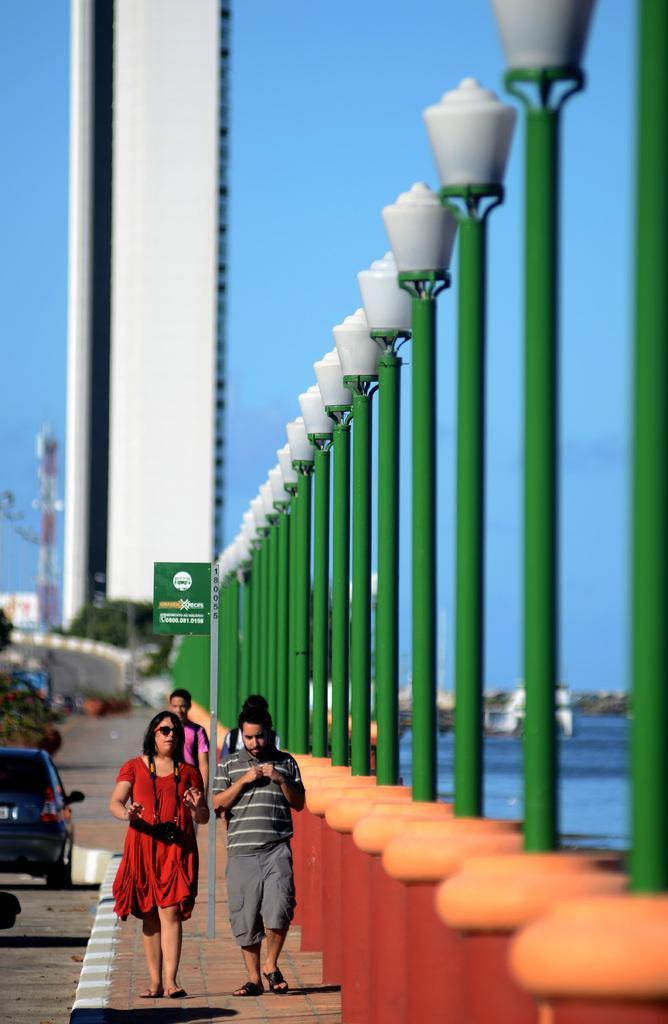Can you describe this image briefly? In this image three people are walking on the sidewalk. On the road there are few vehicles. This is a board. Here there are street lights. This is a water body. In the background there are buildings, towers, trees. 